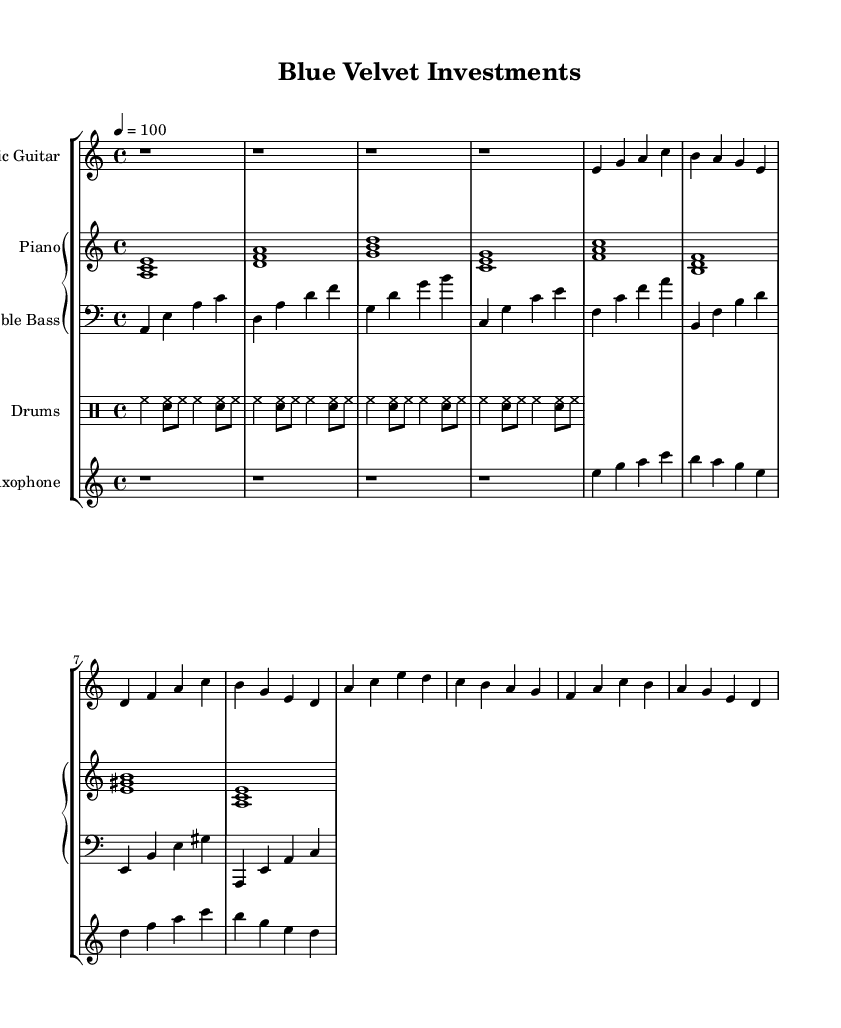What is the key signature of this music? The key signature is A minor, indicated by the presence of no sharps or flats. This is deduced from the 'a' indicated in the key section of the global variable.
Answer: A minor What is the time signature of this music? The time signature is 4/4, which can be found in the global variable section specifying the time division. Each measure consists of four beats.
Answer: 4/4 What is the tempo marking of this piece? The tempo marking indicates 100 beats per minute, which is specified in the global variable under the tempo line.
Answer: 100 How many measures are there in the electric guitar part? By counting the measures in the electric guitar section, there are 8 distinct measures indicated.
Answer: 8 Which instruments are included in this score? The instruments listed in the score are Electric Guitar, Piano, Double Bass, Drums, and Saxophone. This can be determined from the 'instrumentName' statements in the individual parts.
Answer: Electric Guitar, Piano, Double Bass, Drums, Saxophone What unique characteristic of Electric Blues is reflected in this score? The unique characteristic of this Electric Blues piece is its fusion with jazz elements, particularly reflected in the improvisational feel and the use of syncopated rhythms in the piano and saxophone lines. This sophistication caters to an upscale lounge ambiance.
Answer: Fusion with jazz elements What is the style of the drums part? The style of the drums part is swing, which is characterized by the use of hi-hat and snare drum patterns that create a light, bouncy feel, commonly found in rhythm sections of Electric Blues.
Answer: Swing 